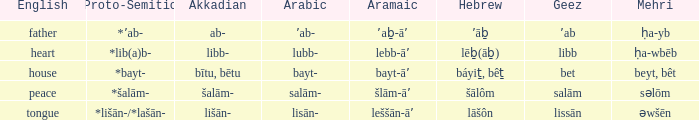If the aramaic is šlām-āʼ, what is the english? Peace. 